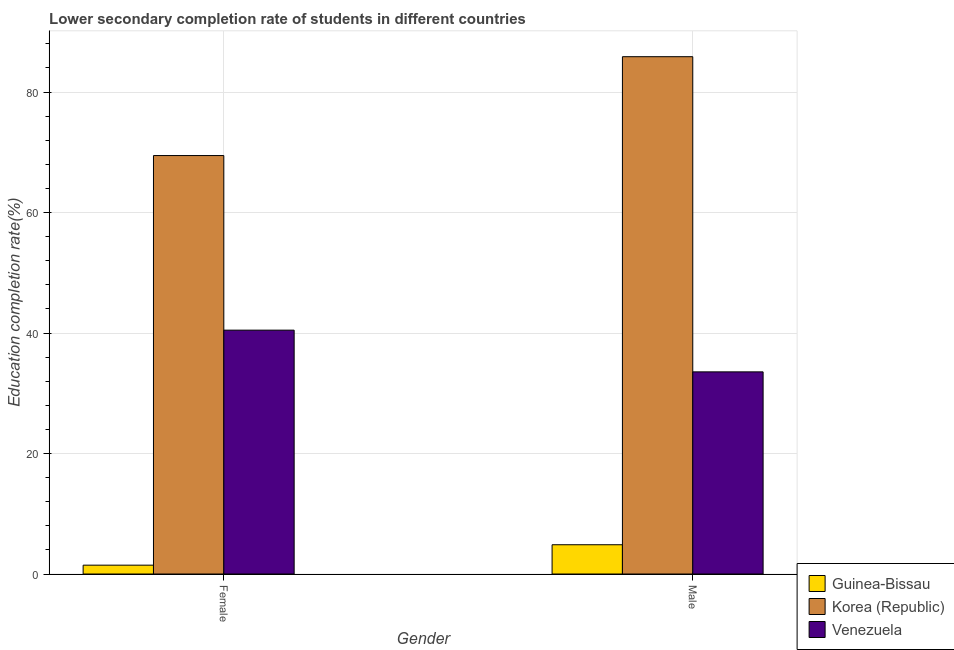Are the number of bars per tick equal to the number of legend labels?
Ensure brevity in your answer.  Yes. How many bars are there on the 2nd tick from the left?
Make the answer very short. 3. What is the education completion rate of female students in Korea (Republic)?
Offer a terse response. 69.47. Across all countries, what is the maximum education completion rate of male students?
Offer a terse response. 85.88. Across all countries, what is the minimum education completion rate of male students?
Provide a short and direct response. 4.86. In which country was the education completion rate of male students minimum?
Provide a short and direct response. Guinea-Bissau. What is the total education completion rate of male students in the graph?
Ensure brevity in your answer.  124.29. What is the difference between the education completion rate of male students in Guinea-Bissau and that in Korea (Republic)?
Your answer should be very brief. -81.02. What is the difference between the education completion rate of female students in Korea (Republic) and the education completion rate of male students in Venezuela?
Ensure brevity in your answer.  35.91. What is the average education completion rate of male students per country?
Keep it short and to the point. 41.43. What is the difference between the education completion rate of female students and education completion rate of male students in Korea (Republic)?
Make the answer very short. -16.41. In how many countries, is the education completion rate of male students greater than 12 %?
Your answer should be very brief. 2. What is the ratio of the education completion rate of male students in Venezuela to that in Guinea-Bissau?
Ensure brevity in your answer.  6.91. Is the education completion rate of male students in Guinea-Bissau less than that in Venezuela?
Give a very brief answer. Yes. What does the 1st bar from the left in Male represents?
Give a very brief answer. Guinea-Bissau. What does the 2nd bar from the right in Female represents?
Give a very brief answer. Korea (Republic). How many bars are there?
Your response must be concise. 6. How many countries are there in the graph?
Offer a very short reply. 3. Where does the legend appear in the graph?
Give a very brief answer. Bottom right. How many legend labels are there?
Give a very brief answer. 3. What is the title of the graph?
Your answer should be compact. Lower secondary completion rate of students in different countries. What is the label or title of the Y-axis?
Your answer should be compact. Education completion rate(%). What is the Education completion rate(%) in Guinea-Bissau in Female?
Make the answer very short. 1.47. What is the Education completion rate(%) in Korea (Republic) in Female?
Give a very brief answer. 69.47. What is the Education completion rate(%) in Venezuela in Female?
Your answer should be compact. 40.48. What is the Education completion rate(%) in Guinea-Bissau in Male?
Make the answer very short. 4.86. What is the Education completion rate(%) of Korea (Republic) in Male?
Your answer should be very brief. 85.88. What is the Education completion rate(%) of Venezuela in Male?
Your answer should be compact. 33.56. Across all Gender, what is the maximum Education completion rate(%) of Guinea-Bissau?
Provide a succinct answer. 4.86. Across all Gender, what is the maximum Education completion rate(%) in Korea (Republic)?
Keep it short and to the point. 85.88. Across all Gender, what is the maximum Education completion rate(%) of Venezuela?
Offer a terse response. 40.48. Across all Gender, what is the minimum Education completion rate(%) in Guinea-Bissau?
Offer a terse response. 1.47. Across all Gender, what is the minimum Education completion rate(%) of Korea (Republic)?
Provide a short and direct response. 69.47. Across all Gender, what is the minimum Education completion rate(%) of Venezuela?
Offer a very short reply. 33.56. What is the total Education completion rate(%) in Guinea-Bissau in the graph?
Your answer should be compact. 6.32. What is the total Education completion rate(%) of Korea (Republic) in the graph?
Your answer should be very brief. 155.34. What is the total Education completion rate(%) in Venezuela in the graph?
Your answer should be compact. 74.04. What is the difference between the Education completion rate(%) of Guinea-Bissau in Female and that in Male?
Your answer should be very brief. -3.39. What is the difference between the Education completion rate(%) of Korea (Republic) in Female and that in Male?
Offer a terse response. -16.41. What is the difference between the Education completion rate(%) of Venezuela in Female and that in Male?
Ensure brevity in your answer.  6.92. What is the difference between the Education completion rate(%) of Guinea-Bissau in Female and the Education completion rate(%) of Korea (Republic) in Male?
Provide a succinct answer. -84.41. What is the difference between the Education completion rate(%) of Guinea-Bissau in Female and the Education completion rate(%) of Venezuela in Male?
Offer a terse response. -32.09. What is the difference between the Education completion rate(%) in Korea (Republic) in Female and the Education completion rate(%) in Venezuela in Male?
Make the answer very short. 35.91. What is the average Education completion rate(%) of Guinea-Bissau per Gender?
Make the answer very short. 3.16. What is the average Education completion rate(%) in Korea (Republic) per Gender?
Offer a terse response. 77.67. What is the average Education completion rate(%) in Venezuela per Gender?
Provide a short and direct response. 37.02. What is the difference between the Education completion rate(%) in Guinea-Bissau and Education completion rate(%) in Korea (Republic) in Female?
Your answer should be compact. -68. What is the difference between the Education completion rate(%) in Guinea-Bissau and Education completion rate(%) in Venezuela in Female?
Your answer should be very brief. -39.02. What is the difference between the Education completion rate(%) of Korea (Republic) and Education completion rate(%) of Venezuela in Female?
Provide a short and direct response. 28.98. What is the difference between the Education completion rate(%) of Guinea-Bissau and Education completion rate(%) of Korea (Republic) in Male?
Your answer should be compact. -81.02. What is the difference between the Education completion rate(%) of Guinea-Bissau and Education completion rate(%) of Venezuela in Male?
Your response must be concise. -28.7. What is the difference between the Education completion rate(%) of Korea (Republic) and Education completion rate(%) of Venezuela in Male?
Provide a succinct answer. 52.32. What is the ratio of the Education completion rate(%) in Guinea-Bissau in Female to that in Male?
Your answer should be very brief. 0.3. What is the ratio of the Education completion rate(%) of Korea (Republic) in Female to that in Male?
Offer a terse response. 0.81. What is the ratio of the Education completion rate(%) of Venezuela in Female to that in Male?
Your answer should be very brief. 1.21. What is the difference between the highest and the second highest Education completion rate(%) of Guinea-Bissau?
Offer a terse response. 3.39. What is the difference between the highest and the second highest Education completion rate(%) of Korea (Republic)?
Keep it short and to the point. 16.41. What is the difference between the highest and the second highest Education completion rate(%) in Venezuela?
Provide a succinct answer. 6.92. What is the difference between the highest and the lowest Education completion rate(%) in Guinea-Bissau?
Your answer should be very brief. 3.39. What is the difference between the highest and the lowest Education completion rate(%) in Korea (Republic)?
Ensure brevity in your answer.  16.41. What is the difference between the highest and the lowest Education completion rate(%) in Venezuela?
Keep it short and to the point. 6.92. 